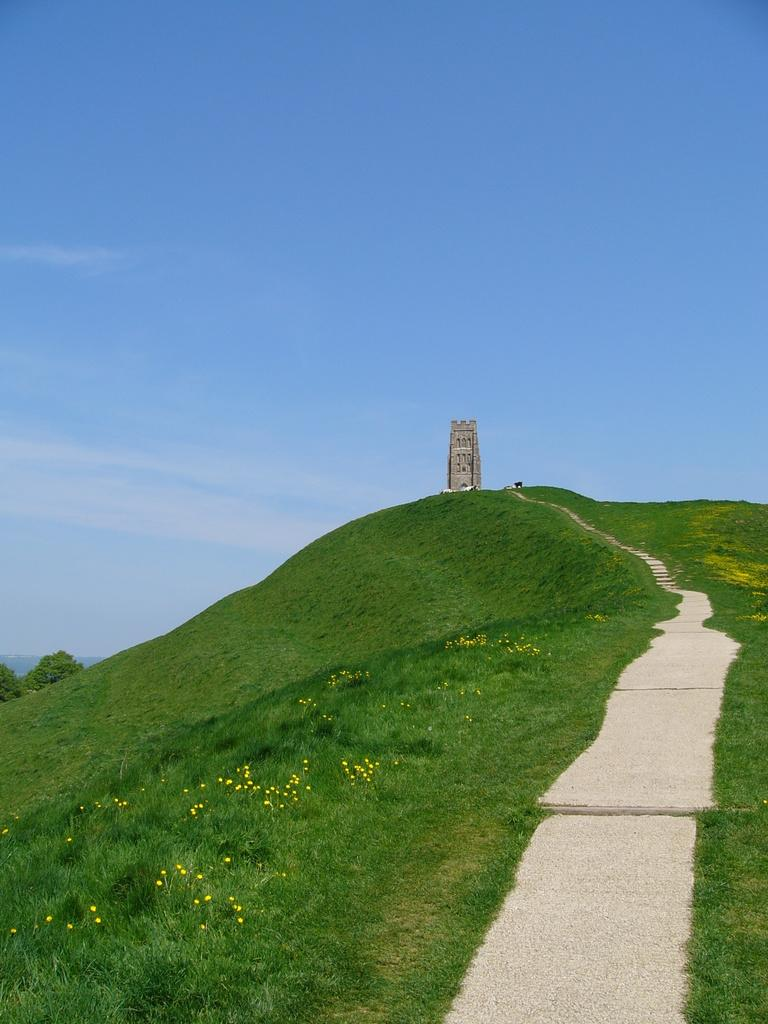What type of vegetation is present in the image? There is grass in the image. Are there any other natural elements in the image? Yes, there are trees in the image. What man-made structure can be seen in the image? There appears to be a monument in the image. How would you describe the sky in the image? The sky is blue and cloudy in the image. Where is the bottle hidden in the image? There is no bottle present in the image. What type of boot can be seen near the monument in the image? There is no boot present near the monument in the image. 